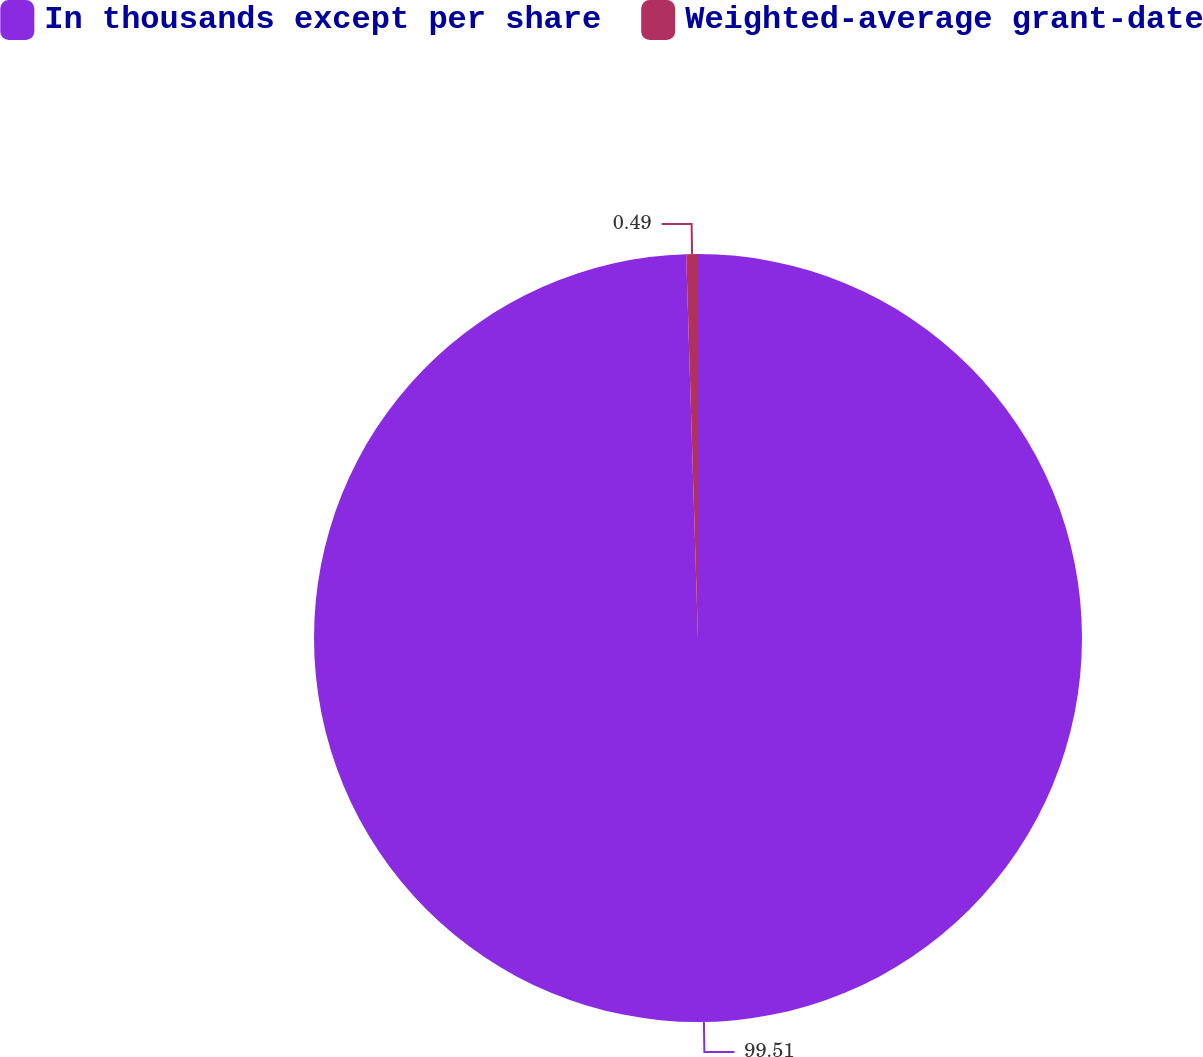Convert chart to OTSL. <chart><loc_0><loc_0><loc_500><loc_500><pie_chart><fcel>In thousands except per share<fcel>Weighted-average grant-date<nl><fcel>99.51%<fcel>0.49%<nl></chart> 